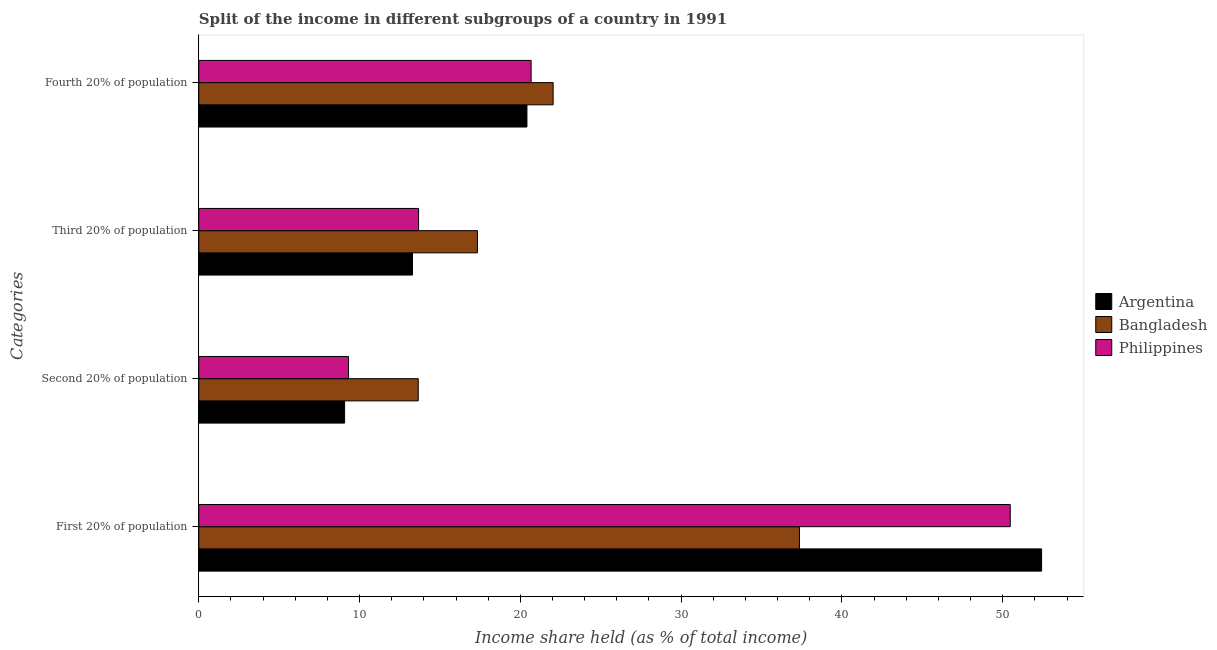How many groups of bars are there?
Your response must be concise. 4. Are the number of bars per tick equal to the number of legend labels?
Ensure brevity in your answer.  Yes. How many bars are there on the 3rd tick from the top?
Provide a short and direct response. 3. How many bars are there on the 3rd tick from the bottom?
Your answer should be compact. 3. What is the label of the 2nd group of bars from the top?
Offer a terse response. Third 20% of population. What is the share of the income held by second 20% of the population in Argentina?
Offer a terse response. 9.07. Across all countries, what is the maximum share of the income held by fourth 20% of the population?
Your response must be concise. 22.04. Across all countries, what is the minimum share of the income held by second 20% of the population?
Keep it short and to the point. 9.07. In which country was the share of the income held by first 20% of the population maximum?
Your answer should be very brief. Argentina. In which country was the share of the income held by fourth 20% of the population minimum?
Offer a very short reply. Argentina. What is the total share of the income held by fourth 20% of the population in the graph?
Offer a very short reply. 63.12. What is the difference between the share of the income held by third 20% of the population in Bangladesh and that in Argentina?
Give a very brief answer. 4.04. What is the difference between the share of the income held by third 20% of the population in Philippines and the share of the income held by first 20% of the population in Argentina?
Offer a terse response. -38.75. What is the average share of the income held by third 20% of the population per country?
Keep it short and to the point. 14.76. What is the difference between the share of the income held by second 20% of the population and share of the income held by fourth 20% of the population in Bangladesh?
Make the answer very short. -8.39. In how many countries, is the share of the income held by fourth 20% of the population greater than 42 %?
Your answer should be very brief. 0. What is the ratio of the share of the income held by fourth 20% of the population in Philippines to that in Bangladesh?
Make the answer very short. 0.94. Is the share of the income held by second 20% of the population in Bangladesh less than that in Argentina?
Provide a short and direct response. No. Is the difference between the share of the income held by second 20% of the population in Argentina and Bangladesh greater than the difference between the share of the income held by first 20% of the population in Argentina and Bangladesh?
Keep it short and to the point. No. What is the difference between the highest and the second highest share of the income held by first 20% of the population?
Give a very brief answer. 1.95. What is the difference between the highest and the lowest share of the income held by first 20% of the population?
Your answer should be compact. 15.06. In how many countries, is the share of the income held by fourth 20% of the population greater than the average share of the income held by fourth 20% of the population taken over all countries?
Your response must be concise. 1. Is the sum of the share of the income held by third 20% of the population in Philippines and Bangladesh greater than the maximum share of the income held by fourth 20% of the population across all countries?
Keep it short and to the point. Yes. Is it the case that in every country, the sum of the share of the income held by fourth 20% of the population and share of the income held by third 20% of the population is greater than the sum of share of the income held by second 20% of the population and share of the income held by first 20% of the population?
Ensure brevity in your answer.  No. Are all the bars in the graph horizontal?
Offer a very short reply. Yes. How many countries are there in the graph?
Ensure brevity in your answer.  3. What is the difference between two consecutive major ticks on the X-axis?
Your response must be concise. 10. Does the graph contain grids?
Give a very brief answer. No. Where does the legend appear in the graph?
Provide a short and direct response. Center right. How are the legend labels stacked?
Give a very brief answer. Vertical. What is the title of the graph?
Your response must be concise. Split of the income in different subgroups of a country in 1991. What is the label or title of the X-axis?
Make the answer very short. Income share held (as % of total income). What is the label or title of the Y-axis?
Give a very brief answer. Categories. What is the Income share held (as % of total income) in Argentina in First 20% of population?
Give a very brief answer. 52.42. What is the Income share held (as % of total income) of Bangladesh in First 20% of population?
Offer a very short reply. 37.36. What is the Income share held (as % of total income) of Philippines in First 20% of population?
Provide a short and direct response. 50.47. What is the Income share held (as % of total income) in Argentina in Second 20% of population?
Make the answer very short. 9.07. What is the Income share held (as % of total income) in Bangladesh in Second 20% of population?
Your answer should be very brief. 13.65. What is the Income share held (as % of total income) in Philippines in Second 20% of population?
Provide a succinct answer. 9.31. What is the Income share held (as % of total income) in Argentina in Third 20% of population?
Your response must be concise. 13.29. What is the Income share held (as % of total income) in Bangladesh in Third 20% of population?
Make the answer very short. 17.33. What is the Income share held (as % of total income) of Philippines in Third 20% of population?
Give a very brief answer. 13.67. What is the Income share held (as % of total income) in Argentina in Fourth 20% of population?
Your response must be concise. 20.41. What is the Income share held (as % of total income) of Bangladesh in Fourth 20% of population?
Keep it short and to the point. 22.04. What is the Income share held (as % of total income) of Philippines in Fourth 20% of population?
Keep it short and to the point. 20.67. Across all Categories, what is the maximum Income share held (as % of total income) of Argentina?
Provide a succinct answer. 52.42. Across all Categories, what is the maximum Income share held (as % of total income) in Bangladesh?
Offer a very short reply. 37.36. Across all Categories, what is the maximum Income share held (as % of total income) in Philippines?
Provide a short and direct response. 50.47. Across all Categories, what is the minimum Income share held (as % of total income) of Argentina?
Provide a short and direct response. 9.07. Across all Categories, what is the minimum Income share held (as % of total income) in Bangladesh?
Your answer should be compact. 13.65. Across all Categories, what is the minimum Income share held (as % of total income) of Philippines?
Your response must be concise. 9.31. What is the total Income share held (as % of total income) of Argentina in the graph?
Ensure brevity in your answer.  95.19. What is the total Income share held (as % of total income) in Bangladesh in the graph?
Ensure brevity in your answer.  90.38. What is the total Income share held (as % of total income) in Philippines in the graph?
Your answer should be very brief. 94.12. What is the difference between the Income share held (as % of total income) of Argentina in First 20% of population and that in Second 20% of population?
Your response must be concise. 43.35. What is the difference between the Income share held (as % of total income) in Bangladesh in First 20% of population and that in Second 20% of population?
Ensure brevity in your answer.  23.71. What is the difference between the Income share held (as % of total income) in Philippines in First 20% of population and that in Second 20% of population?
Provide a succinct answer. 41.16. What is the difference between the Income share held (as % of total income) in Argentina in First 20% of population and that in Third 20% of population?
Make the answer very short. 39.13. What is the difference between the Income share held (as % of total income) in Bangladesh in First 20% of population and that in Third 20% of population?
Ensure brevity in your answer.  20.03. What is the difference between the Income share held (as % of total income) in Philippines in First 20% of population and that in Third 20% of population?
Your answer should be compact. 36.8. What is the difference between the Income share held (as % of total income) in Argentina in First 20% of population and that in Fourth 20% of population?
Offer a very short reply. 32.01. What is the difference between the Income share held (as % of total income) in Bangladesh in First 20% of population and that in Fourth 20% of population?
Make the answer very short. 15.32. What is the difference between the Income share held (as % of total income) in Philippines in First 20% of population and that in Fourth 20% of population?
Keep it short and to the point. 29.8. What is the difference between the Income share held (as % of total income) in Argentina in Second 20% of population and that in Third 20% of population?
Give a very brief answer. -4.22. What is the difference between the Income share held (as % of total income) of Bangladesh in Second 20% of population and that in Third 20% of population?
Provide a short and direct response. -3.68. What is the difference between the Income share held (as % of total income) of Philippines in Second 20% of population and that in Third 20% of population?
Provide a succinct answer. -4.36. What is the difference between the Income share held (as % of total income) of Argentina in Second 20% of population and that in Fourth 20% of population?
Make the answer very short. -11.34. What is the difference between the Income share held (as % of total income) of Bangladesh in Second 20% of population and that in Fourth 20% of population?
Offer a terse response. -8.39. What is the difference between the Income share held (as % of total income) in Philippines in Second 20% of population and that in Fourth 20% of population?
Make the answer very short. -11.36. What is the difference between the Income share held (as % of total income) of Argentina in Third 20% of population and that in Fourth 20% of population?
Your answer should be compact. -7.12. What is the difference between the Income share held (as % of total income) in Bangladesh in Third 20% of population and that in Fourth 20% of population?
Your answer should be compact. -4.71. What is the difference between the Income share held (as % of total income) of Philippines in Third 20% of population and that in Fourth 20% of population?
Your answer should be compact. -7. What is the difference between the Income share held (as % of total income) in Argentina in First 20% of population and the Income share held (as % of total income) in Bangladesh in Second 20% of population?
Your response must be concise. 38.77. What is the difference between the Income share held (as % of total income) in Argentina in First 20% of population and the Income share held (as % of total income) in Philippines in Second 20% of population?
Give a very brief answer. 43.11. What is the difference between the Income share held (as % of total income) in Bangladesh in First 20% of population and the Income share held (as % of total income) in Philippines in Second 20% of population?
Ensure brevity in your answer.  28.05. What is the difference between the Income share held (as % of total income) in Argentina in First 20% of population and the Income share held (as % of total income) in Bangladesh in Third 20% of population?
Provide a succinct answer. 35.09. What is the difference between the Income share held (as % of total income) of Argentina in First 20% of population and the Income share held (as % of total income) of Philippines in Third 20% of population?
Provide a succinct answer. 38.75. What is the difference between the Income share held (as % of total income) of Bangladesh in First 20% of population and the Income share held (as % of total income) of Philippines in Third 20% of population?
Your response must be concise. 23.69. What is the difference between the Income share held (as % of total income) in Argentina in First 20% of population and the Income share held (as % of total income) in Bangladesh in Fourth 20% of population?
Keep it short and to the point. 30.38. What is the difference between the Income share held (as % of total income) of Argentina in First 20% of population and the Income share held (as % of total income) of Philippines in Fourth 20% of population?
Your answer should be compact. 31.75. What is the difference between the Income share held (as % of total income) in Bangladesh in First 20% of population and the Income share held (as % of total income) in Philippines in Fourth 20% of population?
Your answer should be very brief. 16.69. What is the difference between the Income share held (as % of total income) in Argentina in Second 20% of population and the Income share held (as % of total income) in Bangladesh in Third 20% of population?
Offer a terse response. -8.26. What is the difference between the Income share held (as % of total income) of Bangladesh in Second 20% of population and the Income share held (as % of total income) of Philippines in Third 20% of population?
Make the answer very short. -0.02. What is the difference between the Income share held (as % of total income) of Argentina in Second 20% of population and the Income share held (as % of total income) of Bangladesh in Fourth 20% of population?
Your answer should be compact. -12.97. What is the difference between the Income share held (as % of total income) of Argentina in Second 20% of population and the Income share held (as % of total income) of Philippines in Fourth 20% of population?
Your response must be concise. -11.6. What is the difference between the Income share held (as % of total income) in Bangladesh in Second 20% of population and the Income share held (as % of total income) in Philippines in Fourth 20% of population?
Provide a short and direct response. -7.02. What is the difference between the Income share held (as % of total income) of Argentina in Third 20% of population and the Income share held (as % of total income) of Bangladesh in Fourth 20% of population?
Provide a succinct answer. -8.75. What is the difference between the Income share held (as % of total income) of Argentina in Third 20% of population and the Income share held (as % of total income) of Philippines in Fourth 20% of population?
Your answer should be very brief. -7.38. What is the difference between the Income share held (as % of total income) in Bangladesh in Third 20% of population and the Income share held (as % of total income) in Philippines in Fourth 20% of population?
Offer a very short reply. -3.34. What is the average Income share held (as % of total income) of Argentina per Categories?
Provide a short and direct response. 23.8. What is the average Income share held (as % of total income) in Bangladesh per Categories?
Ensure brevity in your answer.  22.59. What is the average Income share held (as % of total income) in Philippines per Categories?
Your response must be concise. 23.53. What is the difference between the Income share held (as % of total income) in Argentina and Income share held (as % of total income) in Bangladesh in First 20% of population?
Ensure brevity in your answer.  15.06. What is the difference between the Income share held (as % of total income) of Argentina and Income share held (as % of total income) of Philippines in First 20% of population?
Give a very brief answer. 1.95. What is the difference between the Income share held (as % of total income) in Bangladesh and Income share held (as % of total income) in Philippines in First 20% of population?
Your answer should be compact. -13.11. What is the difference between the Income share held (as % of total income) of Argentina and Income share held (as % of total income) of Bangladesh in Second 20% of population?
Keep it short and to the point. -4.58. What is the difference between the Income share held (as % of total income) in Argentina and Income share held (as % of total income) in Philippines in Second 20% of population?
Ensure brevity in your answer.  -0.24. What is the difference between the Income share held (as % of total income) in Bangladesh and Income share held (as % of total income) in Philippines in Second 20% of population?
Give a very brief answer. 4.34. What is the difference between the Income share held (as % of total income) in Argentina and Income share held (as % of total income) in Bangladesh in Third 20% of population?
Offer a very short reply. -4.04. What is the difference between the Income share held (as % of total income) in Argentina and Income share held (as % of total income) in Philippines in Third 20% of population?
Provide a short and direct response. -0.38. What is the difference between the Income share held (as % of total income) of Bangladesh and Income share held (as % of total income) of Philippines in Third 20% of population?
Your response must be concise. 3.66. What is the difference between the Income share held (as % of total income) in Argentina and Income share held (as % of total income) in Bangladesh in Fourth 20% of population?
Your answer should be very brief. -1.63. What is the difference between the Income share held (as % of total income) in Argentina and Income share held (as % of total income) in Philippines in Fourth 20% of population?
Offer a terse response. -0.26. What is the difference between the Income share held (as % of total income) in Bangladesh and Income share held (as % of total income) in Philippines in Fourth 20% of population?
Your answer should be very brief. 1.37. What is the ratio of the Income share held (as % of total income) of Argentina in First 20% of population to that in Second 20% of population?
Give a very brief answer. 5.78. What is the ratio of the Income share held (as % of total income) of Bangladesh in First 20% of population to that in Second 20% of population?
Your answer should be very brief. 2.74. What is the ratio of the Income share held (as % of total income) in Philippines in First 20% of population to that in Second 20% of population?
Offer a terse response. 5.42. What is the ratio of the Income share held (as % of total income) of Argentina in First 20% of population to that in Third 20% of population?
Your answer should be compact. 3.94. What is the ratio of the Income share held (as % of total income) in Bangladesh in First 20% of population to that in Third 20% of population?
Provide a succinct answer. 2.16. What is the ratio of the Income share held (as % of total income) in Philippines in First 20% of population to that in Third 20% of population?
Your answer should be very brief. 3.69. What is the ratio of the Income share held (as % of total income) in Argentina in First 20% of population to that in Fourth 20% of population?
Your answer should be compact. 2.57. What is the ratio of the Income share held (as % of total income) of Bangladesh in First 20% of population to that in Fourth 20% of population?
Offer a very short reply. 1.7. What is the ratio of the Income share held (as % of total income) of Philippines in First 20% of population to that in Fourth 20% of population?
Give a very brief answer. 2.44. What is the ratio of the Income share held (as % of total income) in Argentina in Second 20% of population to that in Third 20% of population?
Your response must be concise. 0.68. What is the ratio of the Income share held (as % of total income) in Bangladesh in Second 20% of population to that in Third 20% of population?
Provide a succinct answer. 0.79. What is the ratio of the Income share held (as % of total income) in Philippines in Second 20% of population to that in Third 20% of population?
Ensure brevity in your answer.  0.68. What is the ratio of the Income share held (as % of total income) in Argentina in Second 20% of population to that in Fourth 20% of population?
Provide a succinct answer. 0.44. What is the ratio of the Income share held (as % of total income) in Bangladesh in Second 20% of population to that in Fourth 20% of population?
Offer a terse response. 0.62. What is the ratio of the Income share held (as % of total income) of Philippines in Second 20% of population to that in Fourth 20% of population?
Provide a short and direct response. 0.45. What is the ratio of the Income share held (as % of total income) of Argentina in Third 20% of population to that in Fourth 20% of population?
Your response must be concise. 0.65. What is the ratio of the Income share held (as % of total income) in Bangladesh in Third 20% of population to that in Fourth 20% of population?
Your answer should be compact. 0.79. What is the ratio of the Income share held (as % of total income) in Philippines in Third 20% of population to that in Fourth 20% of population?
Make the answer very short. 0.66. What is the difference between the highest and the second highest Income share held (as % of total income) in Argentina?
Offer a terse response. 32.01. What is the difference between the highest and the second highest Income share held (as % of total income) of Bangladesh?
Provide a succinct answer. 15.32. What is the difference between the highest and the second highest Income share held (as % of total income) in Philippines?
Your answer should be very brief. 29.8. What is the difference between the highest and the lowest Income share held (as % of total income) of Argentina?
Make the answer very short. 43.35. What is the difference between the highest and the lowest Income share held (as % of total income) in Bangladesh?
Offer a terse response. 23.71. What is the difference between the highest and the lowest Income share held (as % of total income) of Philippines?
Offer a very short reply. 41.16. 